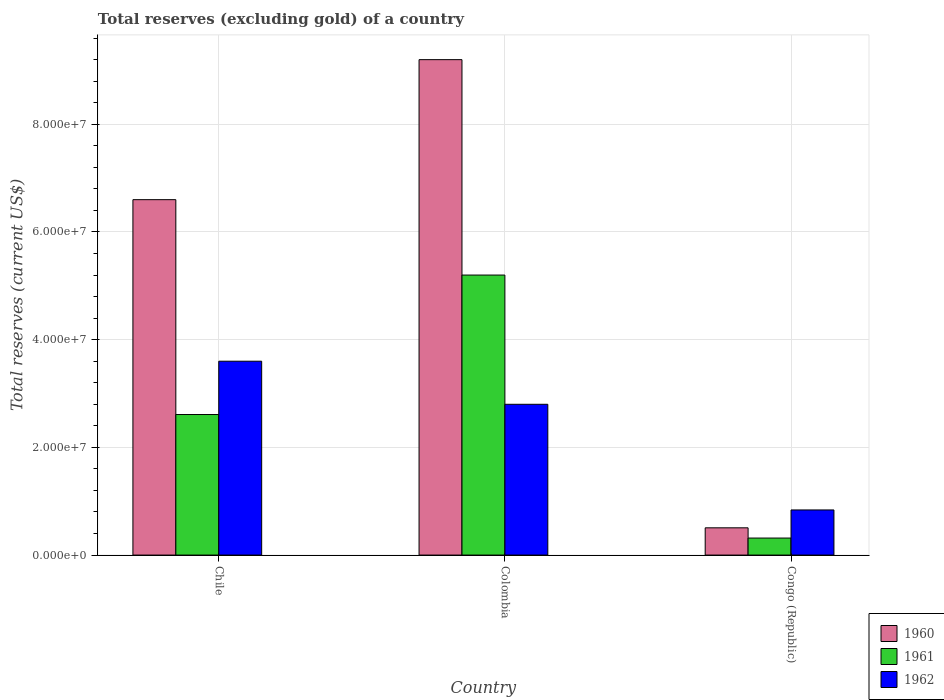How many different coloured bars are there?
Offer a very short reply. 3. How many groups of bars are there?
Make the answer very short. 3. Are the number of bars per tick equal to the number of legend labels?
Keep it short and to the point. Yes. How many bars are there on the 3rd tick from the right?
Provide a succinct answer. 3. What is the label of the 3rd group of bars from the left?
Your answer should be compact. Congo (Republic). What is the total reserves (excluding gold) in 1962 in Chile?
Your response must be concise. 3.60e+07. Across all countries, what is the maximum total reserves (excluding gold) in 1962?
Your answer should be very brief. 3.60e+07. Across all countries, what is the minimum total reserves (excluding gold) in 1960?
Your answer should be compact. 5.06e+06. In which country was the total reserves (excluding gold) in 1962 minimum?
Give a very brief answer. Congo (Republic). What is the total total reserves (excluding gold) in 1960 in the graph?
Keep it short and to the point. 1.63e+08. What is the difference between the total reserves (excluding gold) in 1961 in Chile and that in Congo (Republic)?
Provide a short and direct response. 2.29e+07. What is the difference between the total reserves (excluding gold) in 1961 in Chile and the total reserves (excluding gold) in 1960 in Congo (Republic)?
Offer a terse response. 2.10e+07. What is the average total reserves (excluding gold) in 1960 per country?
Give a very brief answer. 5.44e+07. What is the difference between the total reserves (excluding gold) of/in 1961 and total reserves (excluding gold) of/in 1962 in Congo (Republic)?
Your answer should be compact. -5.22e+06. What is the ratio of the total reserves (excluding gold) in 1962 in Colombia to that in Congo (Republic)?
Keep it short and to the point. 3.34. What is the difference between the highest and the second highest total reserves (excluding gold) in 1960?
Provide a short and direct response. 6.09e+07. What is the difference between the highest and the lowest total reserves (excluding gold) in 1961?
Give a very brief answer. 4.88e+07. In how many countries, is the total reserves (excluding gold) in 1960 greater than the average total reserves (excluding gold) in 1960 taken over all countries?
Offer a very short reply. 2. What does the 2nd bar from the left in Colombia represents?
Make the answer very short. 1961. Are all the bars in the graph horizontal?
Offer a very short reply. No. Does the graph contain any zero values?
Provide a short and direct response. No. What is the title of the graph?
Make the answer very short. Total reserves (excluding gold) of a country. What is the label or title of the X-axis?
Offer a very short reply. Country. What is the label or title of the Y-axis?
Provide a short and direct response. Total reserves (current US$). What is the Total reserves (current US$) in 1960 in Chile?
Make the answer very short. 6.60e+07. What is the Total reserves (current US$) in 1961 in Chile?
Ensure brevity in your answer.  2.61e+07. What is the Total reserves (current US$) of 1962 in Chile?
Keep it short and to the point. 3.60e+07. What is the Total reserves (current US$) of 1960 in Colombia?
Ensure brevity in your answer.  9.20e+07. What is the Total reserves (current US$) of 1961 in Colombia?
Ensure brevity in your answer.  5.20e+07. What is the Total reserves (current US$) in 1962 in Colombia?
Ensure brevity in your answer.  2.80e+07. What is the Total reserves (current US$) in 1960 in Congo (Republic)?
Ensure brevity in your answer.  5.06e+06. What is the Total reserves (current US$) in 1961 in Congo (Republic)?
Give a very brief answer. 3.16e+06. What is the Total reserves (current US$) in 1962 in Congo (Republic)?
Offer a terse response. 8.38e+06. Across all countries, what is the maximum Total reserves (current US$) in 1960?
Provide a succinct answer. 9.20e+07. Across all countries, what is the maximum Total reserves (current US$) in 1961?
Your response must be concise. 5.20e+07. Across all countries, what is the maximum Total reserves (current US$) of 1962?
Keep it short and to the point. 3.60e+07. Across all countries, what is the minimum Total reserves (current US$) in 1960?
Give a very brief answer. 5.06e+06. Across all countries, what is the minimum Total reserves (current US$) in 1961?
Offer a very short reply. 3.16e+06. Across all countries, what is the minimum Total reserves (current US$) of 1962?
Your answer should be very brief. 8.38e+06. What is the total Total reserves (current US$) of 1960 in the graph?
Offer a terse response. 1.63e+08. What is the total Total reserves (current US$) of 1961 in the graph?
Your answer should be compact. 8.13e+07. What is the total Total reserves (current US$) in 1962 in the graph?
Offer a very short reply. 7.24e+07. What is the difference between the Total reserves (current US$) of 1960 in Chile and that in Colombia?
Keep it short and to the point. -2.60e+07. What is the difference between the Total reserves (current US$) in 1961 in Chile and that in Colombia?
Provide a short and direct response. -2.59e+07. What is the difference between the Total reserves (current US$) of 1960 in Chile and that in Congo (Republic)?
Offer a very short reply. 6.09e+07. What is the difference between the Total reserves (current US$) of 1961 in Chile and that in Congo (Republic)?
Offer a terse response. 2.29e+07. What is the difference between the Total reserves (current US$) in 1962 in Chile and that in Congo (Republic)?
Ensure brevity in your answer.  2.76e+07. What is the difference between the Total reserves (current US$) of 1960 in Colombia and that in Congo (Republic)?
Keep it short and to the point. 8.69e+07. What is the difference between the Total reserves (current US$) in 1961 in Colombia and that in Congo (Republic)?
Ensure brevity in your answer.  4.88e+07. What is the difference between the Total reserves (current US$) in 1962 in Colombia and that in Congo (Republic)?
Make the answer very short. 1.96e+07. What is the difference between the Total reserves (current US$) of 1960 in Chile and the Total reserves (current US$) of 1961 in Colombia?
Keep it short and to the point. 1.40e+07. What is the difference between the Total reserves (current US$) in 1960 in Chile and the Total reserves (current US$) in 1962 in Colombia?
Give a very brief answer. 3.80e+07. What is the difference between the Total reserves (current US$) of 1961 in Chile and the Total reserves (current US$) of 1962 in Colombia?
Make the answer very short. -1.90e+06. What is the difference between the Total reserves (current US$) in 1960 in Chile and the Total reserves (current US$) in 1961 in Congo (Republic)?
Offer a very short reply. 6.28e+07. What is the difference between the Total reserves (current US$) of 1960 in Chile and the Total reserves (current US$) of 1962 in Congo (Republic)?
Make the answer very short. 5.76e+07. What is the difference between the Total reserves (current US$) of 1961 in Chile and the Total reserves (current US$) of 1962 in Congo (Republic)?
Your answer should be compact. 1.77e+07. What is the difference between the Total reserves (current US$) of 1960 in Colombia and the Total reserves (current US$) of 1961 in Congo (Republic)?
Provide a succinct answer. 8.88e+07. What is the difference between the Total reserves (current US$) of 1960 in Colombia and the Total reserves (current US$) of 1962 in Congo (Republic)?
Provide a short and direct response. 8.36e+07. What is the difference between the Total reserves (current US$) in 1961 in Colombia and the Total reserves (current US$) in 1962 in Congo (Republic)?
Your answer should be very brief. 4.36e+07. What is the average Total reserves (current US$) in 1960 per country?
Offer a terse response. 5.44e+07. What is the average Total reserves (current US$) in 1961 per country?
Provide a short and direct response. 2.71e+07. What is the average Total reserves (current US$) of 1962 per country?
Your answer should be compact. 2.41e+07. What is the difference between the Total reserves (current US$) of 1960 and Total reserves (current US$) of 1961 in Chile?
Provide a succinct answer. 3.99e+07. What is the difference between the Total reserves (current US$) of 1960 and Total reserves (current US$) of 1962 in Chile?
Your answer should be compact. 3.00e+07. What is the difference between the Total reserves (current US$) in 1961 and Total reserves (current US$) in 1962 in Chile?
Provide a succinct answer. -9.90e+06. What is the difference between the Total reserves (current US$) of 1960 and Total reserves (current US$) of 1961 in Colombia?
Your answer should be compact. 4.00e+07. What is the difference between the Total reserves (current US$) of 1960 and Total reserves (current US$) of 1962 in Colombia?
Make the answer very short. 6.40e+07. What is the difference between the Total reserves (current US$) in 1961 and Total reserves (current US$) in 1962 in Colombia?
Your answer should be compact. 2.40e+07. What is the difference between the Total reserves (current US$) of 1960 and Total reserves (current US$) of 1961 in Congo (Republic)?
Keep it short and to the point. 1.90e+06. What is the difference between the Total reserves (current US$) of 1960 and Total reserves (current US$) of 1962 in Congo (Republic)?
Ensure brevity in your answer.  -3.32e+06. What is the difference between the Total reserves (current US$) of 1961 and Total reserves (current US$) of 1962 in Congo (Republic)?
Offer a very short reply. -5.22e+06. What is the ratio of the Total reserves (current US$) in 1960 in Chile to that in Colombia?
Make the answer very short. 0.72. What is the ratio of the Total reserves (current US$) of 1961 in Chile to that in Colombia?
Your answer should be compact. 0.5. What is the ratio of the Total reserves (current US$) in 1960 in Chile to that in Congo (Republic)?
Make the answer very short. 13.04. What is the ratio of the Total reserves (current US$) of 1961 in Chile to that in Congo (Republic)?
Your response must be concise. 8.26. What is the ratio of the Total reserves (current US$) in 1962 in Chile to that in Congo (Republic)?
Provide a succinct answer. 4.3. What is the ratio of the Total reserves (current US$) in 1960 in Colombia to that in Congo (Republic)?
Offer a terse response. 18.18. What is the ratio of the Total reserves (current US$) of 1961 in Colombia to that in Congo (Republic)?
Your answer should be very brief. 16.46. What is the ratio of the Total reserves (current US$) of 1962 in Colombia to that in Congo (Republic)?
Give a very brief answer. 3.34. What is the difference between the highest and the second highest Total reserves (current US$) in 1960?
Your answer should be compact. 2.60e+07. What is the difference between the highest and the second highest Total reserves (current US$) of 1961?
Offer a terse response. 2.59e+07. What is the difference between the highest and the lowest Total reserves (current US$) of 1960?
Make the answer very short. 8.69e+07. What is the difference between the highest and the lowest Total reserves (current US$) in 1961?
Offer a terse response. 4.88e+07. What is the difference between the highest and the lowest Total reserves (current US$) of 1962?
Provide a short and direct response. 2.76e+07. 